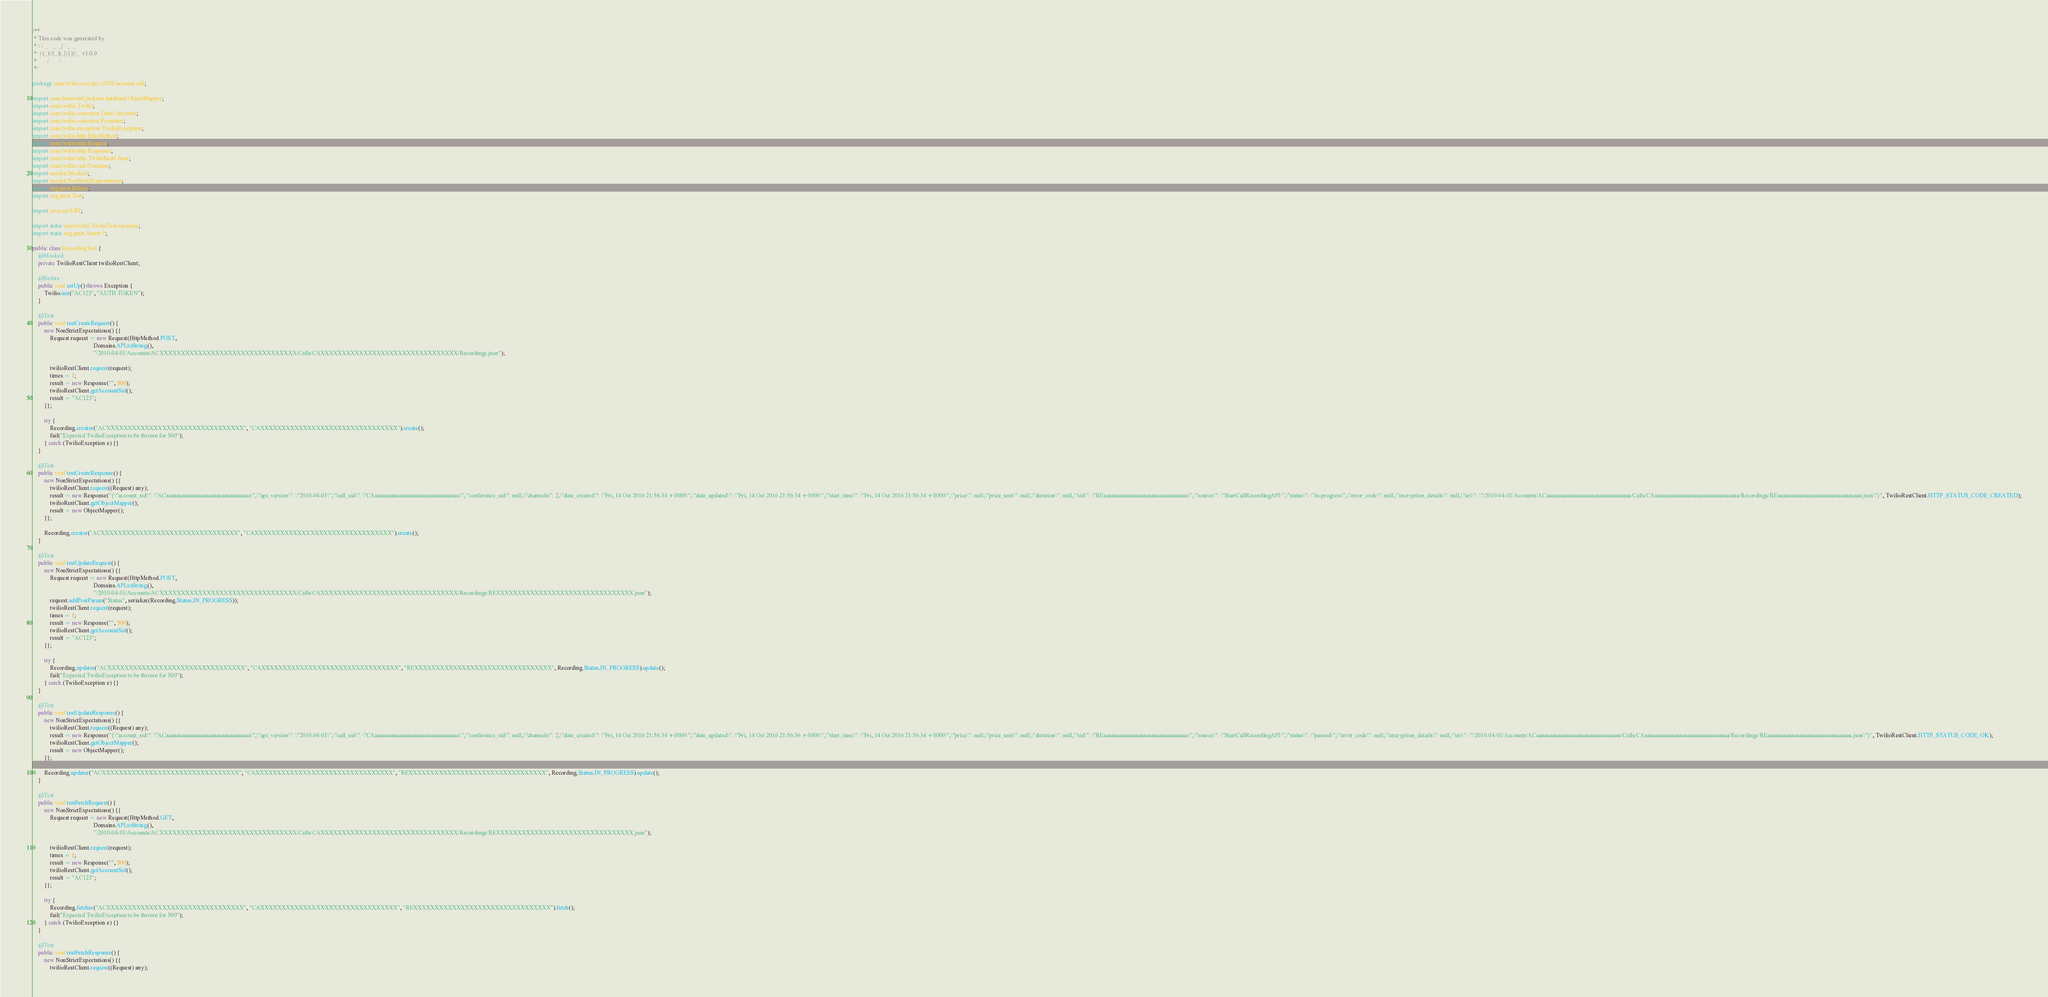Convert code to text. <code><loc_0><loc_0><loc_500><loc_500><_Java_>/**
 * This code was generated by
 * \ / _    _  _|   _  _
 *  | (_)\/(_)(_|\/| |(/_  v1.0.0
 *       /       /
 */

package com.twilio.rest.api.v2010.account.call;

import com.fasterxml.jackson.databind.ObjectMapper;
import com.twilio.Twilio;
import com.twilio.converter.DateConverter;
import com.twilio.converter.Promoter;
import com.twilio.exception.TwilioException;
import com.twilio.http.HttpMethod;
import com.twilio.http.Request;
import com.twilio.http.Response;
import com.twilio.http.TwilioRestClient;
import com.twilio.rest.Domains;
import mockit.Mocked;
import mockit.NonStrictExpectations;
import org.junit.Before;
import org.junit.Test;

import java.net.URI;

import static com.twilio.TwilioTest.serialize;
import static org.junit.Assert.*;

public class RecordingTest {
    @Mocked
    private TwilioRestClient twilioRestClient;

    @Before
    public void setUp() throws Exception {
        Twilio.init("AC123", "AUTH TOKEN");
    }

    @Test
    public void testCreateRequest() {
        new NonStrictExpectations() {{
            Request request = new Request(HttpMethod.POST,
                                          Domains.API.toString(),
                                          "/2010-04-01/Accounts/ACXXXXXXXXXXXXXXXXXXXXXXXXXXXXXXXX/Calls/CAXXXXXXXXXXXXXXXXXXXXXXXXXXXXXXXX/Recordings.json");

            twilioRestClient.request(request);
            times = 1;
            result = new Response("", 500);
            twilioRestClient.getAccountSid();
            result = "AC123";
        }};

        try {
            Recording.creator("ACXXXXXXXXXXXXXXXXXXXXXXXXXXXXXXXX", "CAXXXXXXXXXXXXXXXXXXXXXXXXXXXXXXXX").create();
            fail("Expected TwilioException to be thrown for 500");
        } catch (TwilioException e) {}
    }

    @Test
    public void testCreateResponse() {
        new NonStrictExpectations() {{
            twilioRestClient.request((Request) any);
            result = new Response("{\"account_sid\": \"ACaaaaaaaaaaaaaaaaaaaaaaaaaaaaaaaa\",\"api_version\": \"2010-04-01\",\"call_sid\": \"CAaaaaaaaaaaaaaaaaaaaaaaaaaaaaaaaa\",\"conference_sid\": null,\"channels\": 2,\"date_created\": \"Fri, 14 Oct 2016 21:56:34 +0000\",\"date_updated\": \"Fri, 14 Oct 2016 21:56:34 +0000\",\"start_time\": \"Fri, 14 Oct 2016 21:56:34 +0000\",\"price\": null,\"price_unit\": null,\"duration\": null,\"sid\": \"REaaaaaaaaaaaaaaaaaaaaaaaaaaaaaaaa\",\"source\": \"StartCallRecordingAPI\",\"status\": \"in-progress\",\"error_code\": null,\"encryption_details\": null,\"uri\": \"/2010-04-01/Accounts/ACaaaaaaaaaaaaaaaaaaaaaaaaaaaaaaaa/Calls/CAaaaaaaaaaaaaaaaaaaaaaaaaaaaaaaaa/Recordings/REaaaaaaaaaaaaaaaaaaaaaaaaaaaaaaaa.json\"}", TwilioRestClient.HTTP_STATUS_CODE_CREATED);
            twilioRestClient.getObjectMapper();
            result = new ObjectMapper();
        }};

        Recording.creator("ACXXXXXXXXXXXXXXXXXXXXXXXXXXXXXXXX", "CAXXXXXXXXXXXXXXXXXXXXXXXXXXXXXXXX").create();
    }

    @Test
    public void testUpdateRequest() {
        new NonStrictExpectations() {{
            Request request = new Request(HttpMethod.POST,
                                          Domains.API.toString(),
                                          "/2010-04-01/Accounts/ACXXXXXXXXXXXXXXXXXXXXXXXXXXXXXXXX/Calls/CAXXXXXXXXXXXXXXXXXXXXXXXXXXXXXXXX/Recordings/REXXXXXXXXXXXXXXXXXXXXXXXXXXXXXXXX.json");
            request.addPostParam("Status", serialize(Recording.Status.IN_PROGRESS));
            twilioRestClient.request(request);
            times = 1;
            result = new Response("", 500);
            twilioRestClient.getAccountSid();
            result = "AC123";
        }};

        try {
            Recording.updater("ACXXXXXXXXXXXXXXXXXXXXXXXXXXXXXXXX", "CAXXXXXXXXXXXXXXXXXXXXXXXXXXXXXXXX", "REXXXXXXXXXXXXXXXXXXXXXXXXXXXXXXXX", Recording.Status.IN_PROGRESS).update();
            fail("Expected TwilioException to be thrown for 500");
        } catch (TwilioException e) {}
    }

    @Test
    public void testUpdateResponse() {
        new NonStrictExpectations() {{
            twilioRestClient.request((Request) any);
            result = new Response("{\"account_sid\": \"ACaaaaaaaaaaaaaaaaaaaaaaaaaaaaaaaa\",\"api_version\": \"2010-04-01\",\"call_sid\": \"CAaaaaaaaaaaaaaaaaaaaaaaaaaaaaaaaa\",\"conference_sid\": null,\"channels\": 2,\"date_created\": \"Fri, 14 Oct 2016 21:56:34 +0000\",\"date_updated\": \"Fri, 14 Oct 2016 21:56:36 +0000\",\"start_time\": \"Fri, 14 Oct 2016 21:56:34 +0000\",\"price\": null,\"price_unit\": null,\"duration\": null,\"sid\": \"REaaaaaaaaaaaaaaaaaaaaaaaaaaaaaaaa\",\"source\": \"StartCallRecordingAPI\",\"status\": \"paused\",\"error_code\": null,\"encryption_details\": null,\"uri\": \"/2010-04-01/Accounts/ACaaaaaaaaaaaaaaaaaaaaaaaaaaaaaaaa/Calls/CAaaaaaaaaaaaaaaaaaaaaaaaaaaaaaaaa/Recordings/REaaaaaaaaaaaaaaaaaaaaaaaaaaaaaaaa.json\"}", TwilioRestClient.HTTP_STATUS_CODE_OK);
            twilioRestClient.getObjectMapper();
            result = new ObjectMapper();
        }};

        Recording.updater("ACXXXXXXXXXXXXXXXXXXXXXXXXXXXXXXXX", "CAXXXXXXXXXXXXXXXXXXXXXXXXXXXXXXXX", "REXXXXXXXXXXXXXXXXXXXXXXXXXXXXXXXX", Recording.Status.IN_PROGRESS).update();
    }

    @Test
    public void testFetchRequest() {
        new NonStrictExpectations() {{
            Request request = new Request(HttpMethod.GET,
                                          Domains.API.toString(),
                                          "/2010-04-01/Accounts/ACXXXXXXXXXXXXXXXXXXXXXXXXXXXXXXXX/Calls/CAXXXXXXXXXXXXXXXXXXXXXXXXXXXXXXXX/Recordings/REXXXXXXXXXXXXXXXXXXXXXXXXXXXXXXXX.json");

            twilioRestClient.request(request);
            times = 1;
            result = new Response("", 500);
            twilioRestClient.getAccountSid();
            result = "AC123";
        }};

        try {
            Recording.fetcher("ACXXXXXXXXXXXXXXXXXXXXXXXXXXXXXXXX", "CAXXXXXXXXXXXXXXXXXXXXXXXXXXXXXXXX", "REXXXXXXXXXXXXXXXXXXXXXXXXXXXXXXXX").fetch();
            fail("Expected TwilioException to be thrown for 500");
        } catch (TwilioException e) {}
    }

    @Test
    public void testFetchResponse() {
        new NonStrictExpectations() {{
            twilioRestClient.request((Request) any);</code> 